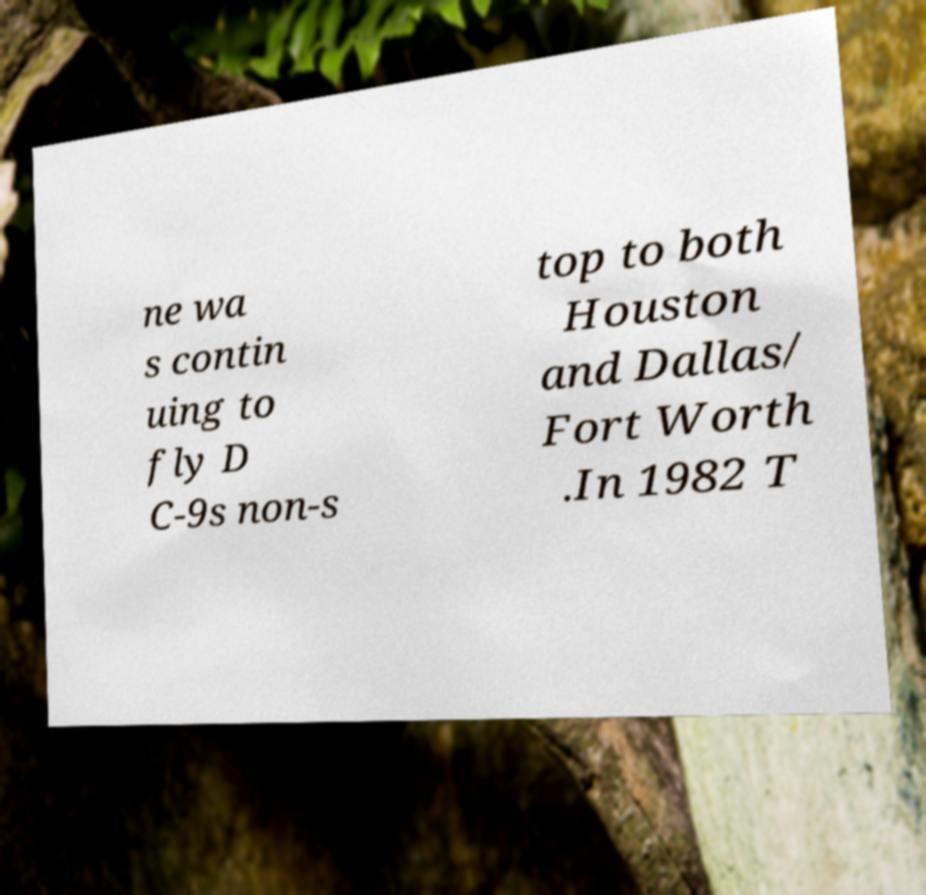Could you assist in decoding the text presented in this image and type it out clearly? ne wa s contin uing to fly D C-9s non-s top to both Houston and Dallas/ Fort Worth .In 1982 T 